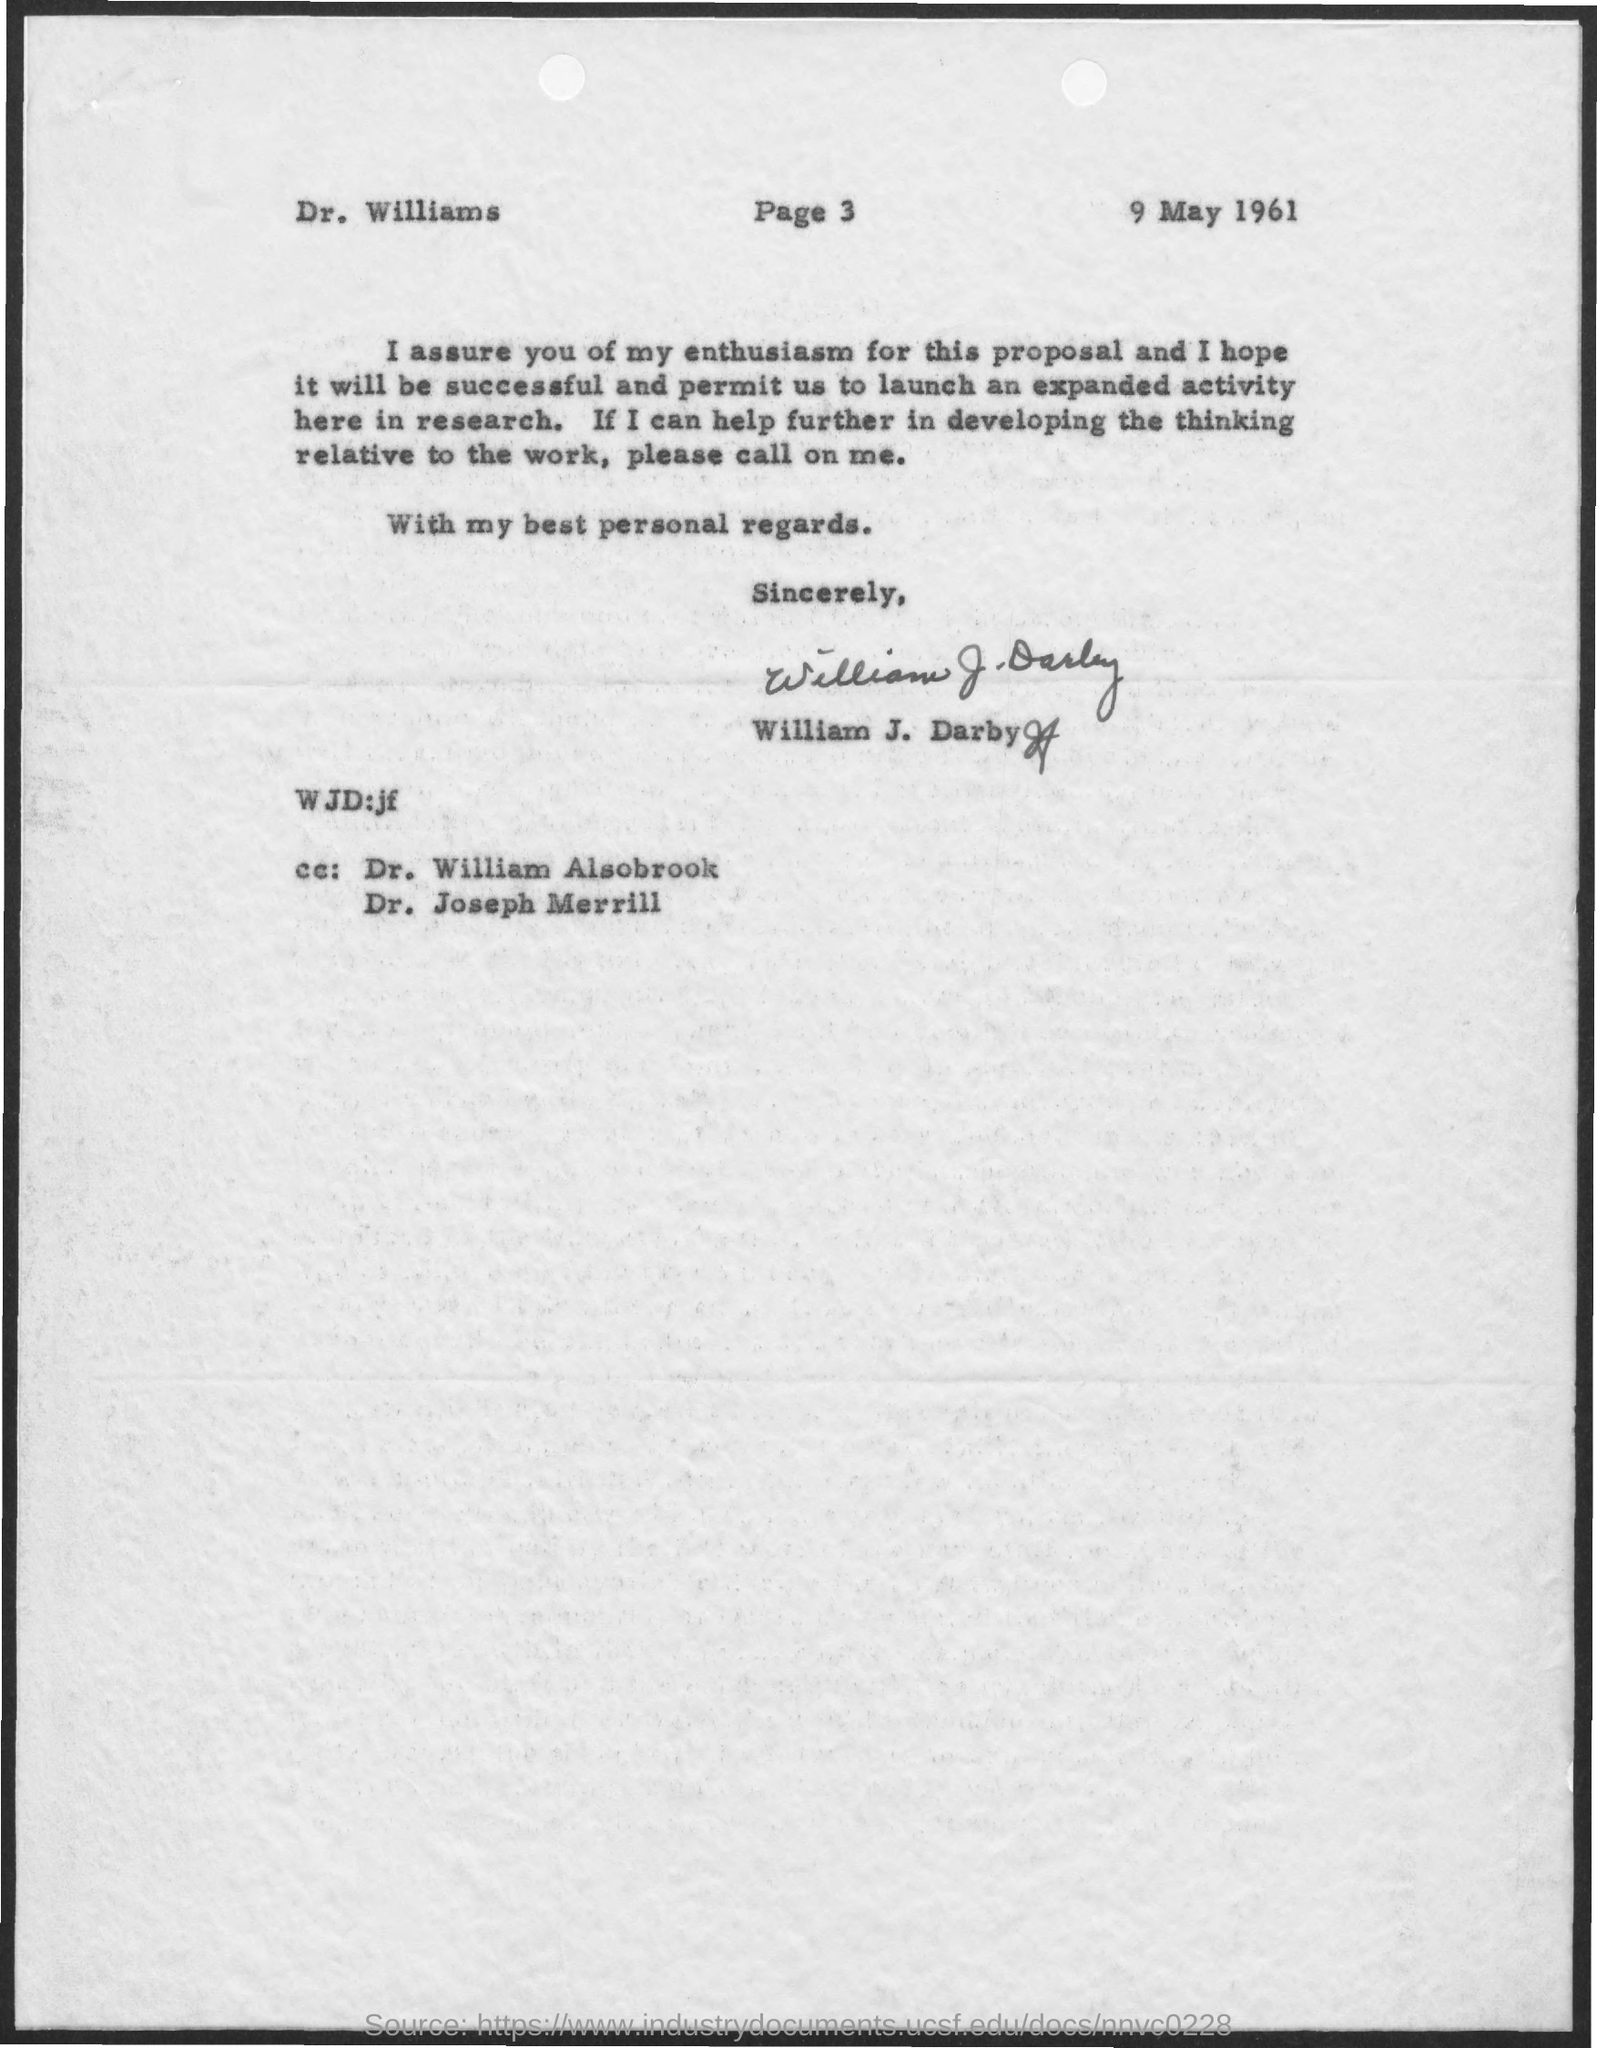List a handful of essential elements in this visual. The letter is addressed to Dr. Williams. The document indicates that the date is May 9, 1961. The letter is from William J. Darby. 